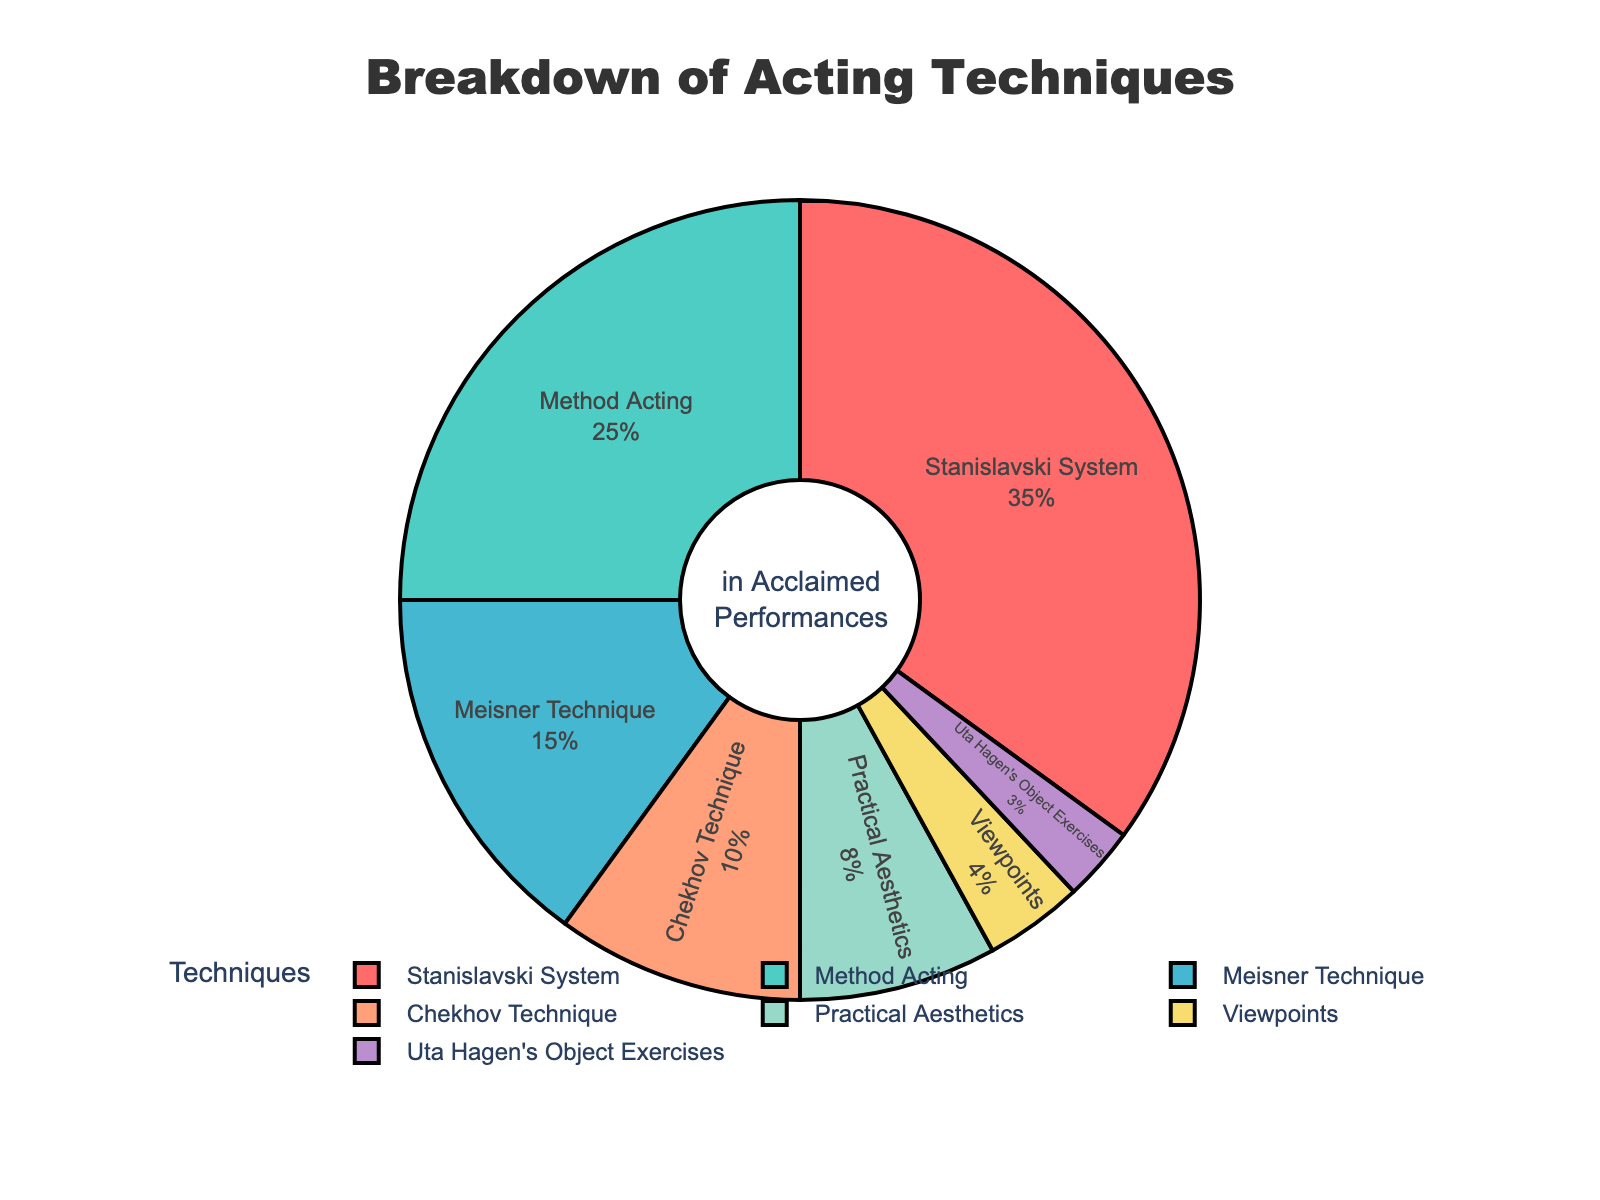What percentage of your performances used the Stanislavski System technique? Locate the section labeled "Stanislavski System" and read the corresponding percentage from the figure.
Answer: 35% Which technique appears to be the second most used in your performances? Identify the technique with the second highest percentage value in the pie chart.
Answer: Method Acting What's the sum of the percentages for the two least used techniques? Add the percentages of the two sections that have the smallest values, which are "Viewpoints" (4%) and "Uta Hagen's Object Exercises" (3%).
Answer: 7% Is the percentage of performances using Method Acting greater than those using Meisner Technique? Compare the percentage values of "Method Acting" (25%) and "Meisner Technique" (15%).
Answer: Yes What is the color representing the Practical Aesthetics technique on the chart? Identify the section labeled "Practical Aesthetics" and describe its color.
Answer: Yellow Which technique has the smallest percentage, and how much of your performances did it comprise? Locate the section with the lowest percentage value and read its label and percentage.
Answer: Uta Hagen's Object Exercises, 3% How many techniques have a usage percentage of less than 10%? Count the sections in the pie chart where the percentage values are less than 10%.
Answer: 3 Which techniques together account for more than half of all techniques used in your performances? Sum the percentages of the techniques until the total exceeds 50%. "Stanislavski System" (35%) + "Method Acting" (25%) = 60%. These two techniques together make up more than half.
Answer: Stanislavski System and Method Acting By how much does the percentage of the Stanislavski System exceed the Meisner Technique? Subtract the percentage of the "Meisner Technique" (15%) from the "Stanislavski System" (35%).
Answer: 20% 